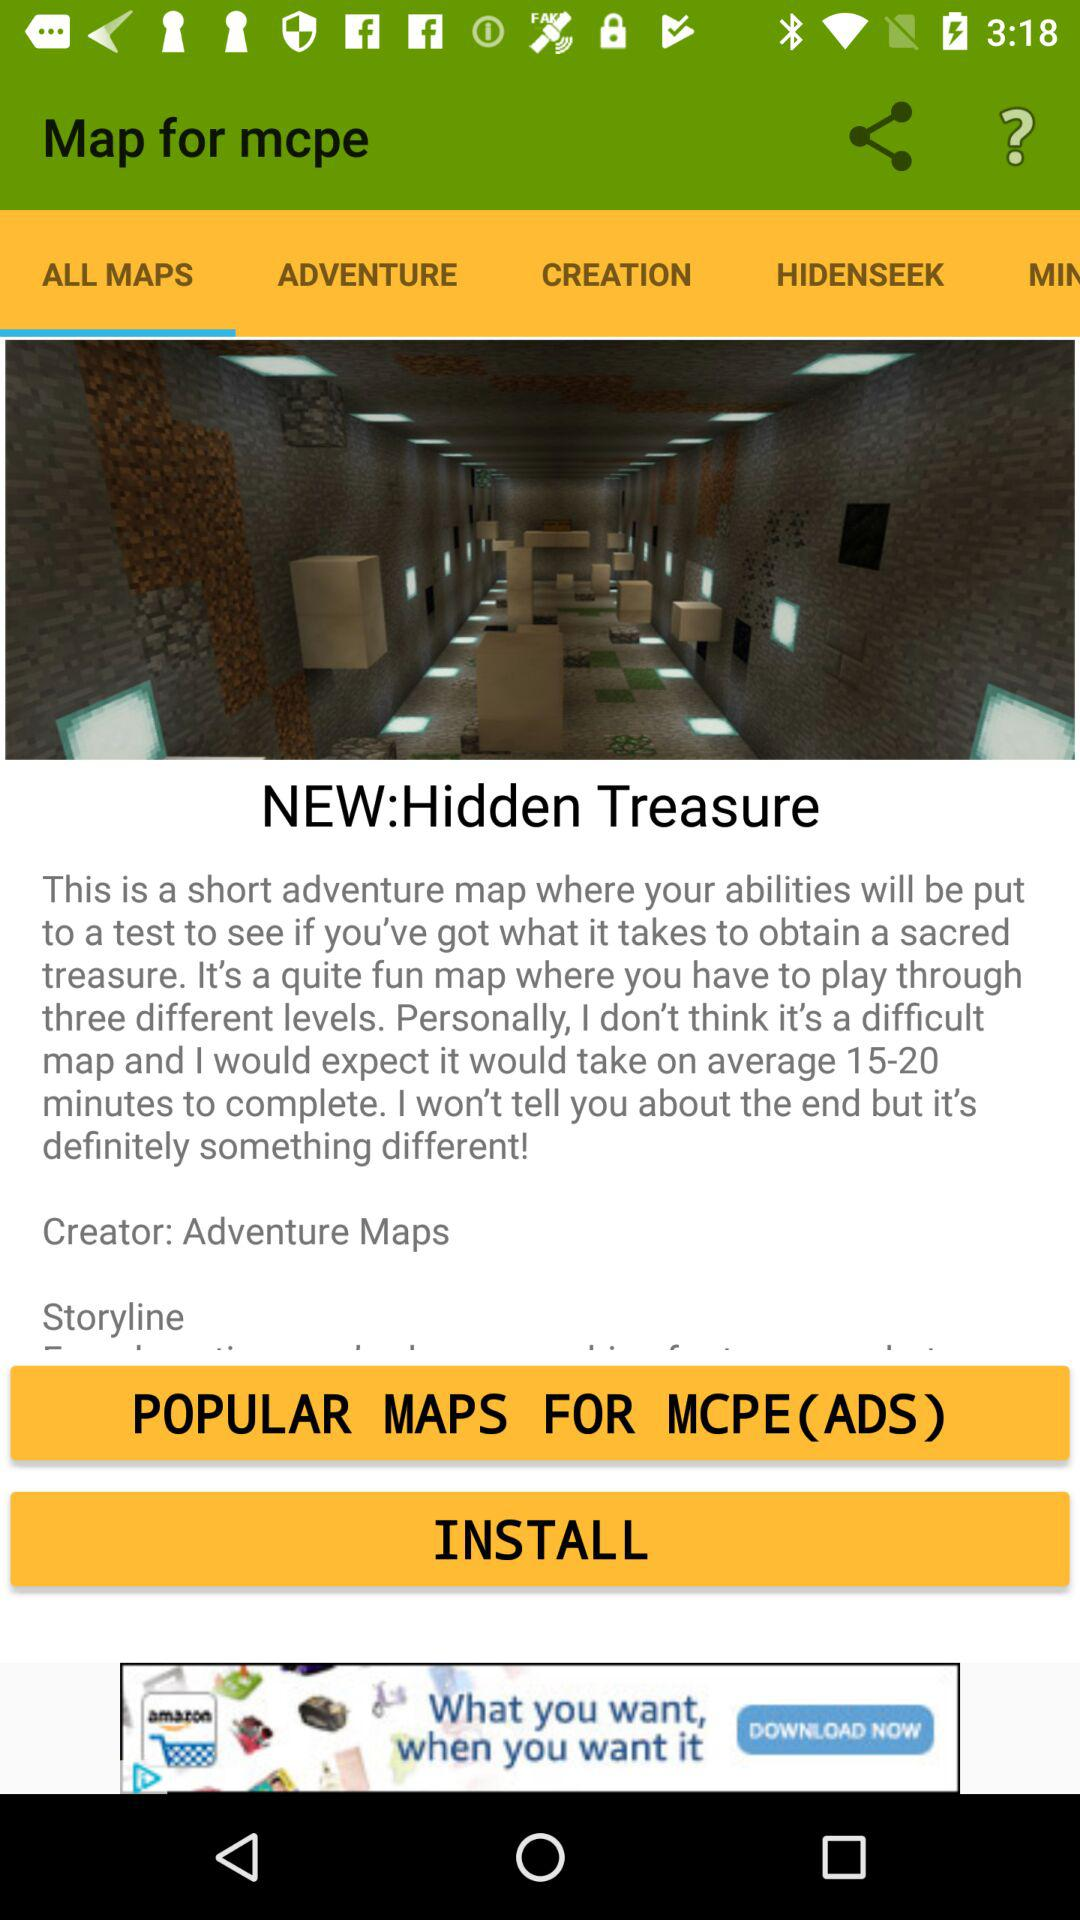How many different levels are there? There are three different levels. 